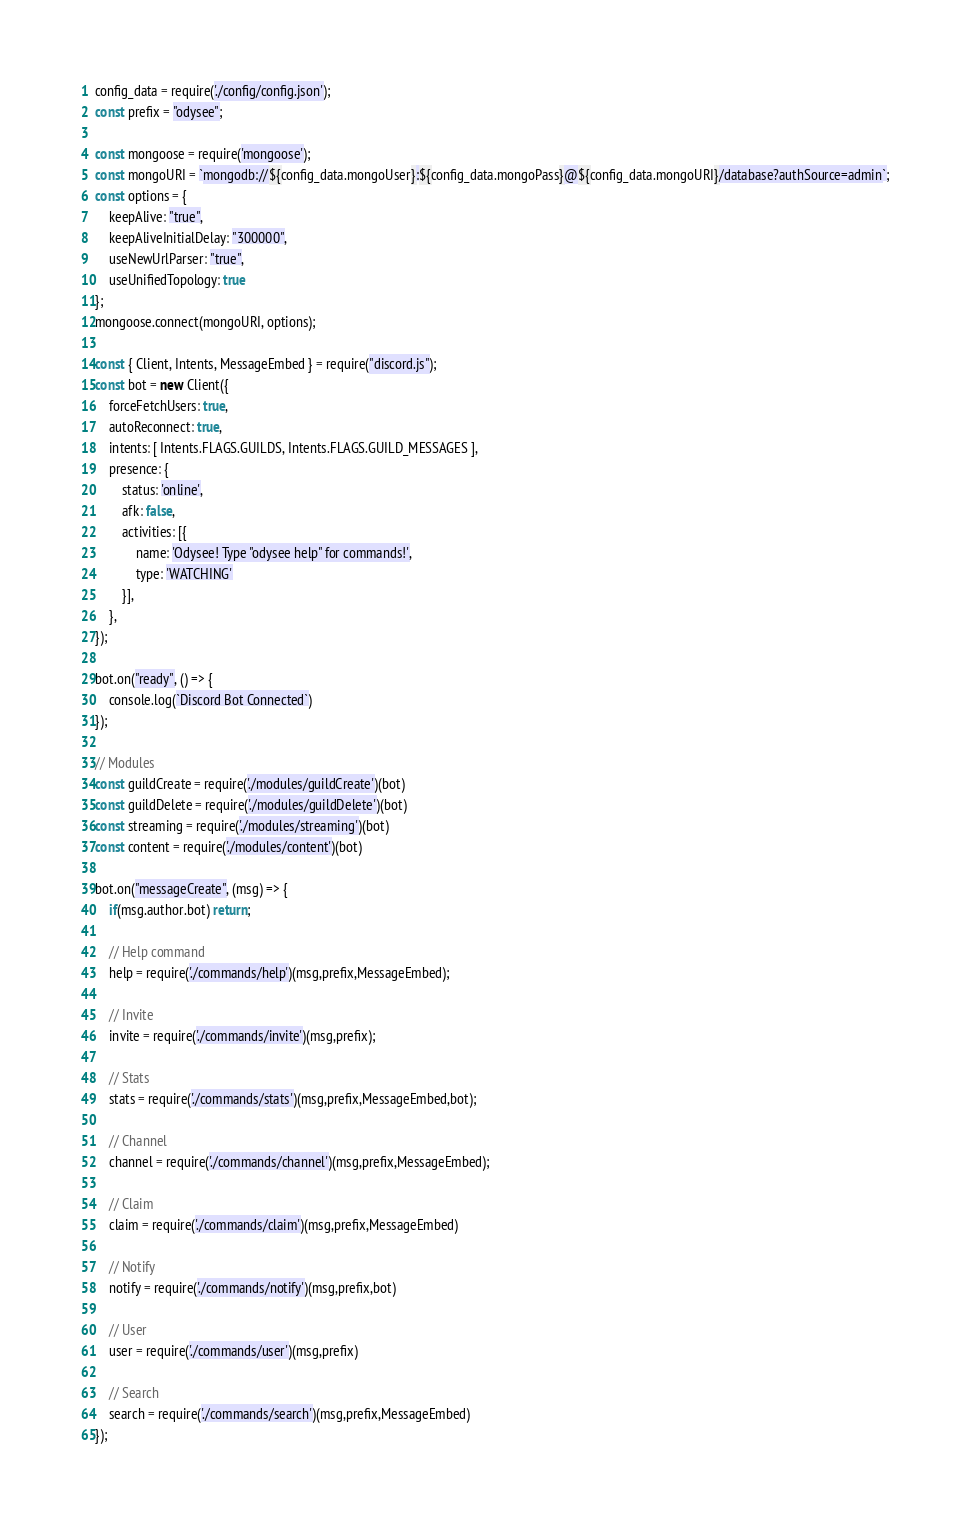Convert code to text. <code><loc_0><loc_0><loc_500><loc_500><_JavaScript_>config_data = require('./config/config.json');
const prefix = "odysee";

const mongoose = require('mongoose');
const mongoURI = `mongodb://${config_data.mongoUser}:${config_data.mongoPass}@${config_data.mongoURI}/database?authSource=admin`;
const options = {
    keepAlive: "true",
    keepAliveInitialDelay: "300000",
    useNewUrlParser: "true",
	useUnifiedTopology: true
};
mongoose.connect(mongoURI, options);

const { Client, Intents, MessageEmbed } = require("discord.js");
const bot = new Client({
	forceFetchUsers: true,
	autoReconnect: true,
	intents: [ Intents.FLAGS.GUILDS, Intents.FLAGS.GUILD_MESSAGES ],
	presence: {
        status: 'online',
        afk: false,
        activities: [{
            name: 'Odysee! Type "odysee help" for commands!',
            type: 'WATCHING'
        }],
    },
});

bot.on("ready", () => {
	console.log(`Discord Bot Connected`)
});

// Modules
const guildCreate = require('./modules/guildCreate')(bot)
const guildDelete = require('./modules/guildDelete')(bot)
const streaming = require('./modules/streaming')(bot)
const content = require('./modules/content')(bot)

bot.on("messageCreate", (msg) => {
	if(msg.author.bot) return;

    // Help command
    help = require('./commands/help')(msg,prefix,MessageEmbed);

    // Invite
    invite = require('./commands/invite')(msg,prefix);

    // Stats
    stats = require('./commands/stats')(msg,prefix,MessageEmbed,bot);

    // Channel
    channel = require('./commands/channel')(msg,prefix,MessageEmbed);

    // Claim
    claim = require('./commands/claim')(msg,prefix,MessageEmbed)

    // Notify
    notify = require('./commands/notify')(msg,prefix,bot)

    // User
    user = require('./commands/user')(msg,prefix)

    // Search
    search = require('./commands/search')(msg,prefix,MessageEmbed)
});
</code> 